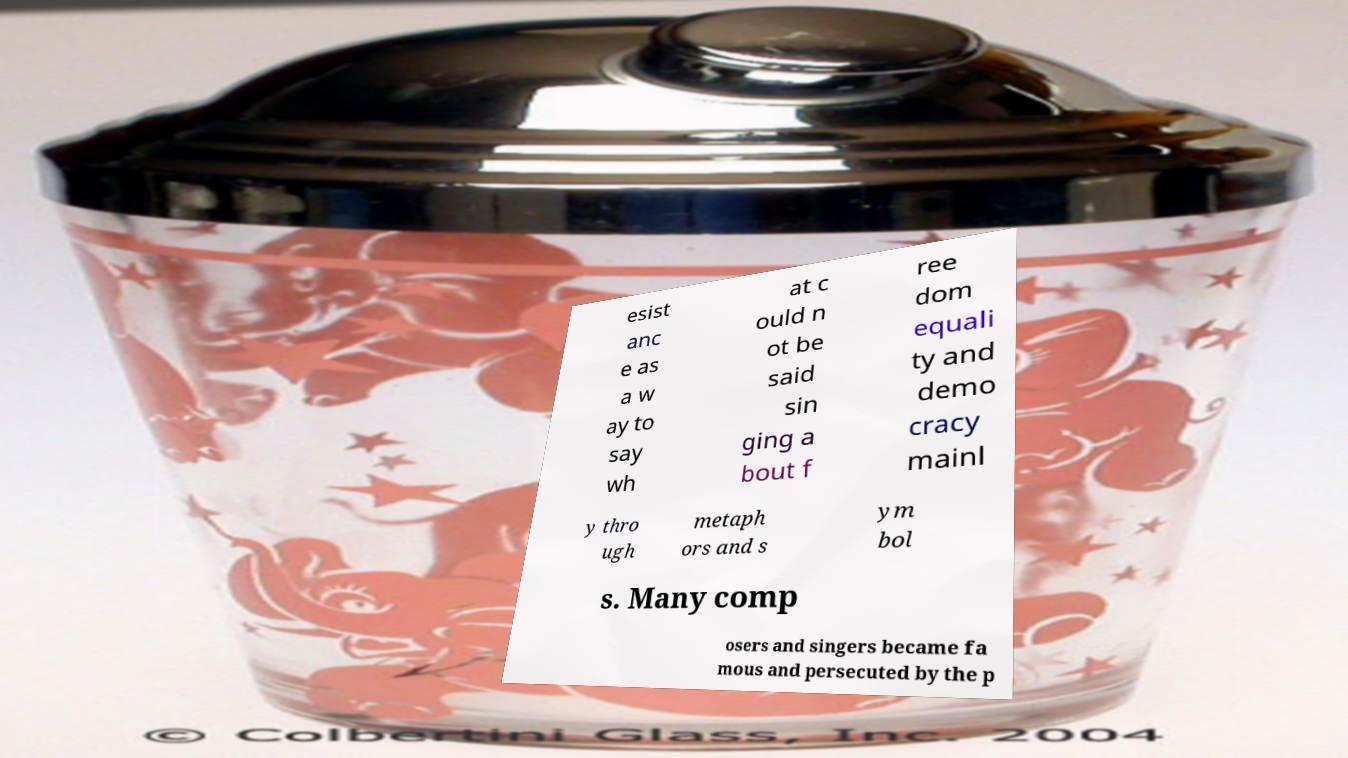Can you accurately transcribe the text from the provided image for me? esist anc e as a w ay to say wh at c ould n ot be said sin ging a bout f ree dom equali ty and demo cracy mainl y thro ugh metaph ors and s ym bol s. Many comp osers and singers became fa mous and persecuted by the p 